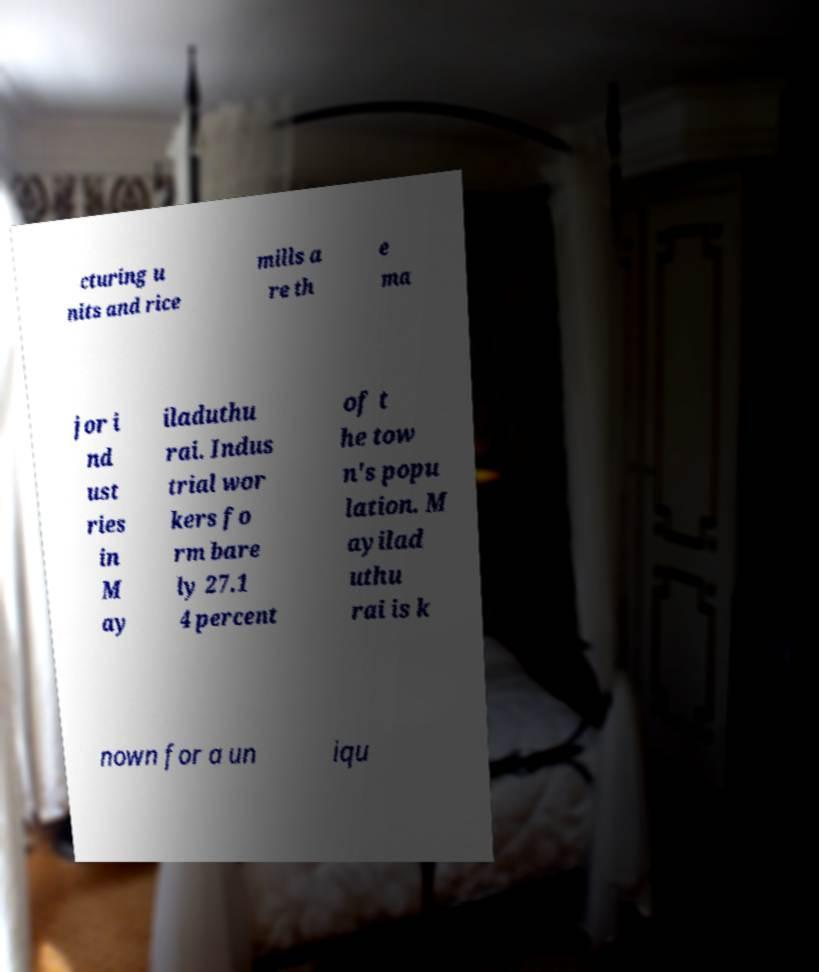Can you accurately transcribe the text from the provided image for me? cturing u nits and rice mills a re th e ma jor i nd ust ries in M ay iladuthu rai. Indus trial wor kers fo rm bare ly 27.1 4 percent of t he tow n's popu lation. M ayilad uthu rai is k nown for a un iqu 